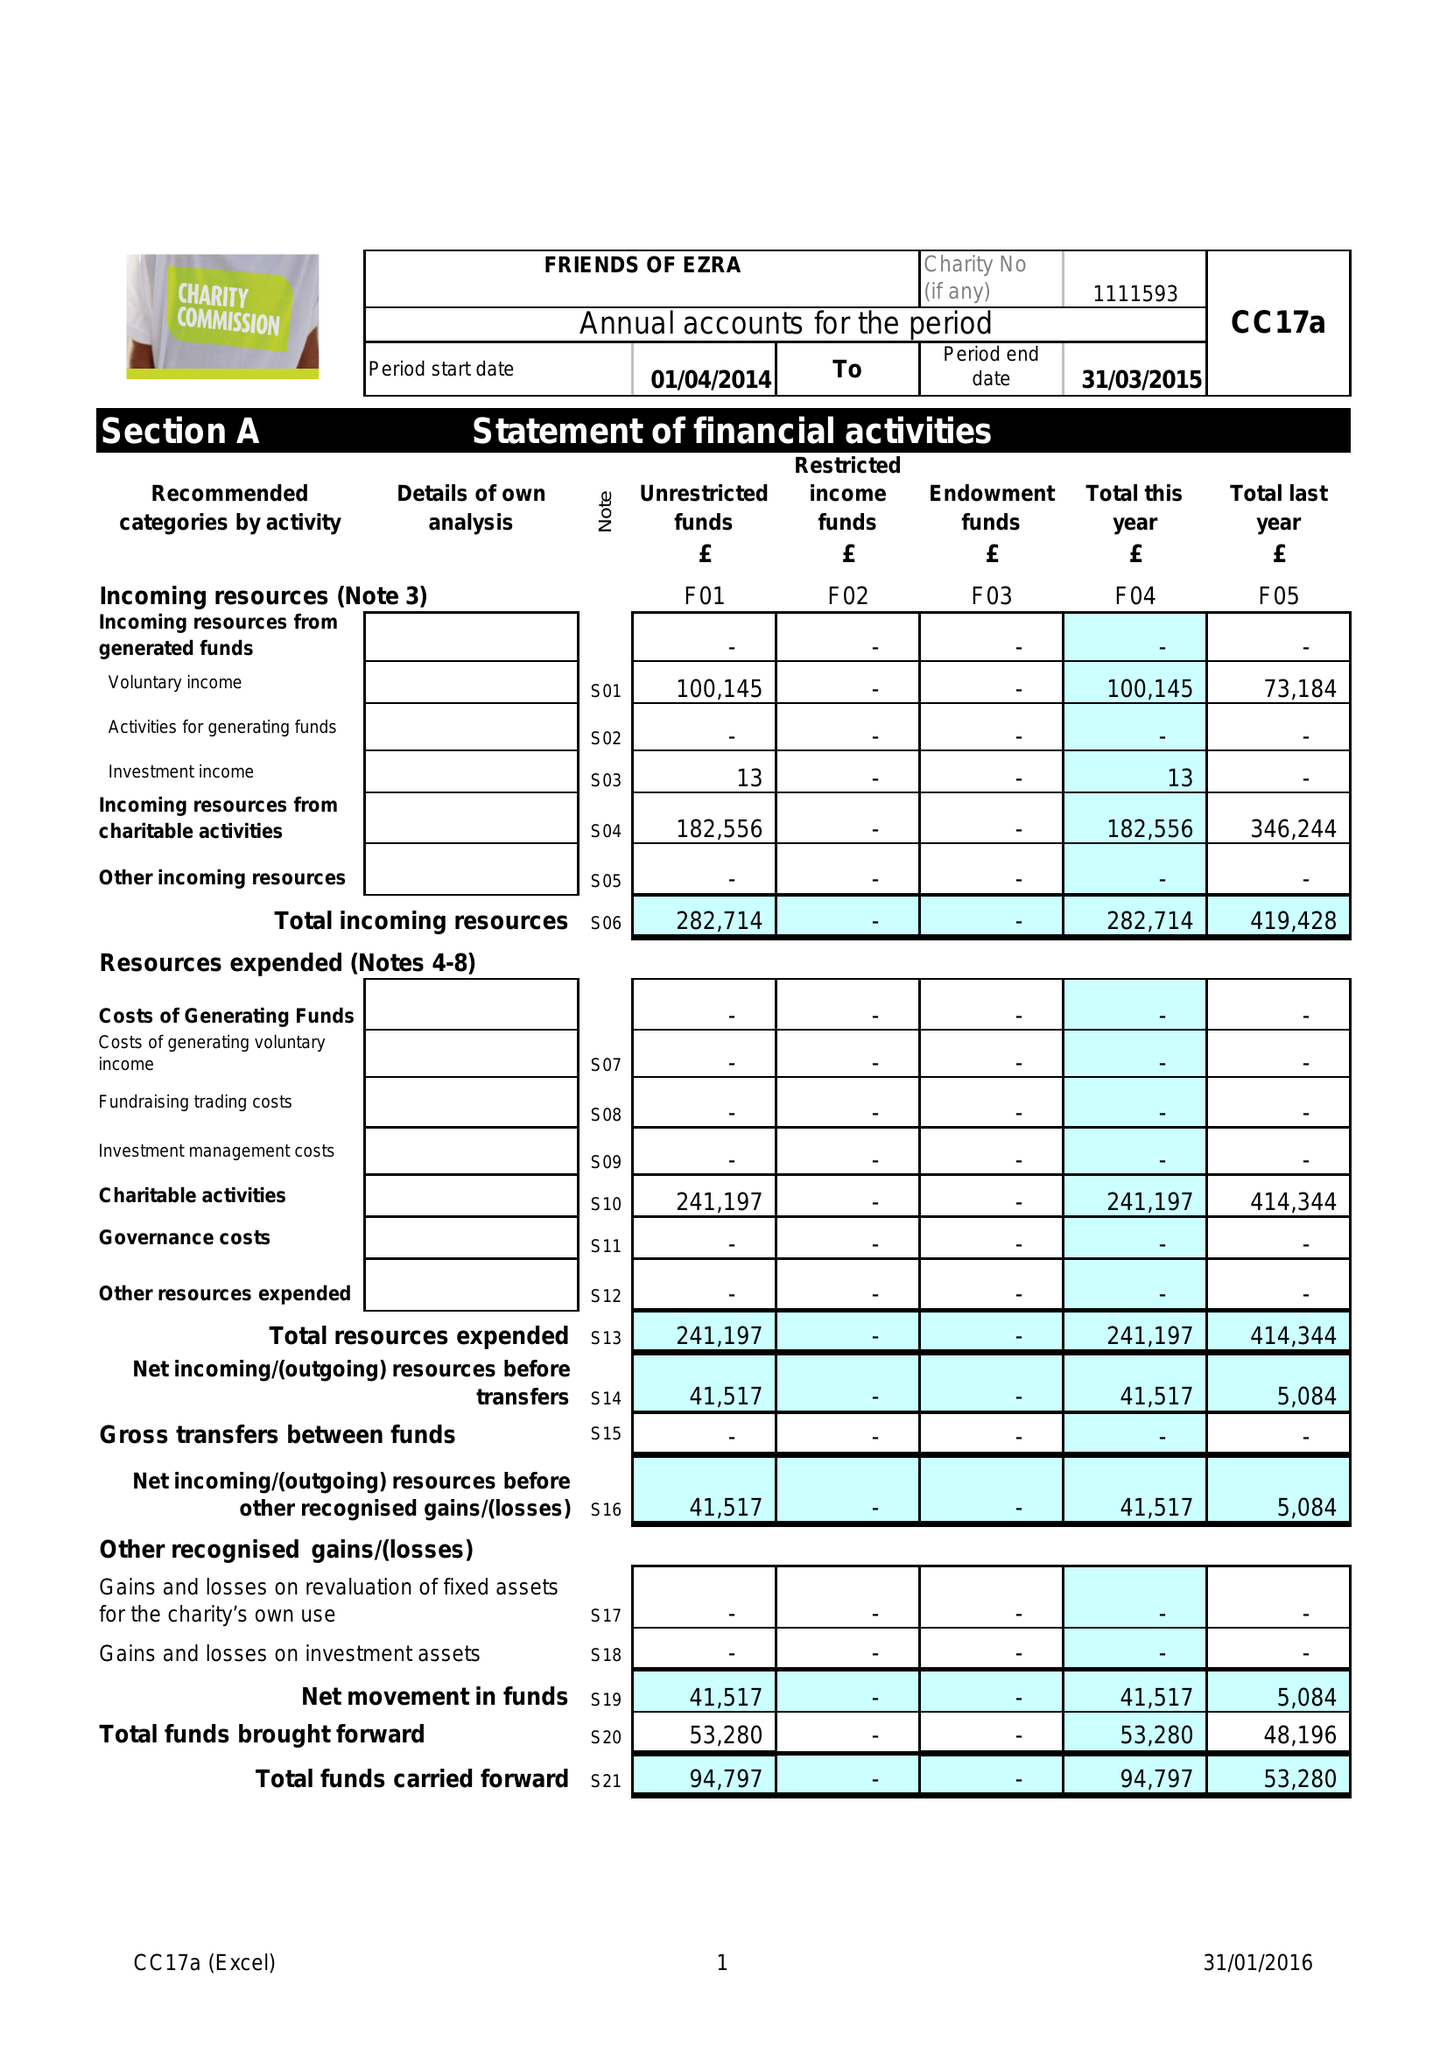What is the value for the charity_name?
Answer the question using a single word or phrase. Friends Of Ezra 